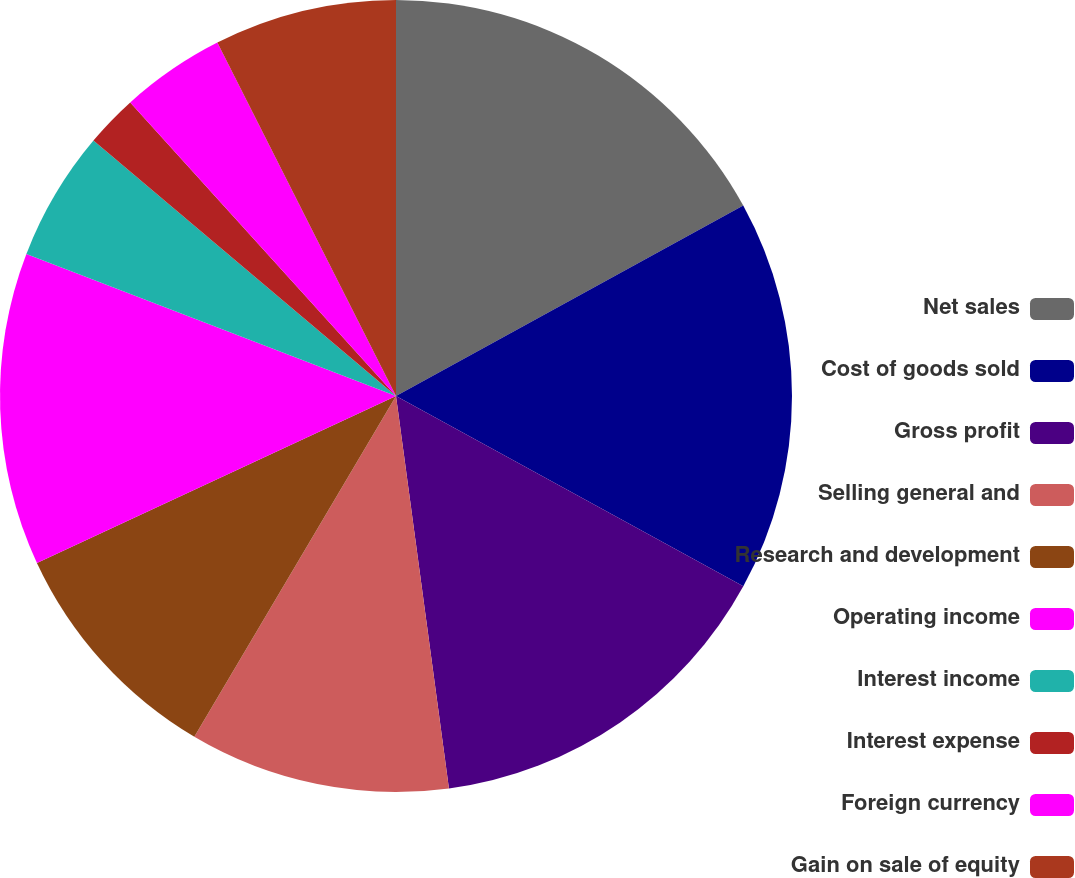Convert chart to OTSL. <chart><loc_0><loc_0><loc_500><loc_500><pie_chart><fcel>Net sales<fcel>Cost of goods sold<fcel>Gross profit<fcel>Selling general and<fcel>Research and development<fcel>Operating income<fcel>Interest income<fcel>Interest expense<fcel>Foreign currency<fcel>Gain on sale of equity<nl><fcel>17.02%<fcel>15.96%<fcel>14.89%<fcel>10.64%<fcel>9.57%<fcel>12.77%<fcel>5.32%<fcel>2.13%<fcel>4.26%<fcel>7.45%<nl></chart> 